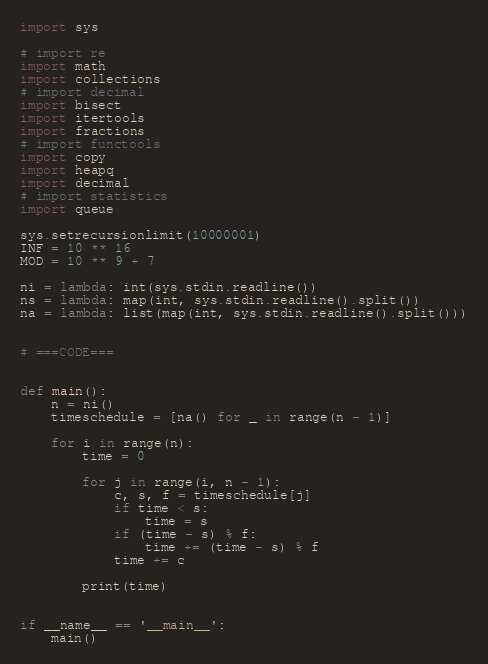Convert code to text. <code><loc_0><loc_0><loc_500><loc_500><_Python_>import sys

# import re
import math
import collections
# import decimal
import bisect
import itertools
import fractions
# import functools
import copy
import heapq
import decimal
# import statistics
import queue

sys.setrecursionlimit(10000001)
INF = 10 ** 16
MOD = 10 ** 9 + 7

ni = lambda: int(sys.stdin.readline())
ns = lambda: map(int, sys.stdin.readline().split())
na = lambda: list(map(int, sys.stdin.readline().split()))


# ===CODE===


def main():
    n = ni()
    timeschedule = [na() for _ in range(n - 1)]

    for i in range(n):
        time = 0

        for j in range(i, n - 1):
            c, s, f = timeschedule[j]
            if time < s:
                time = s
            if (time - s) % f:
                time += (time - s) % f
            time += c

        print(time)


if __name__ == '__main__':
    main()
</code> 